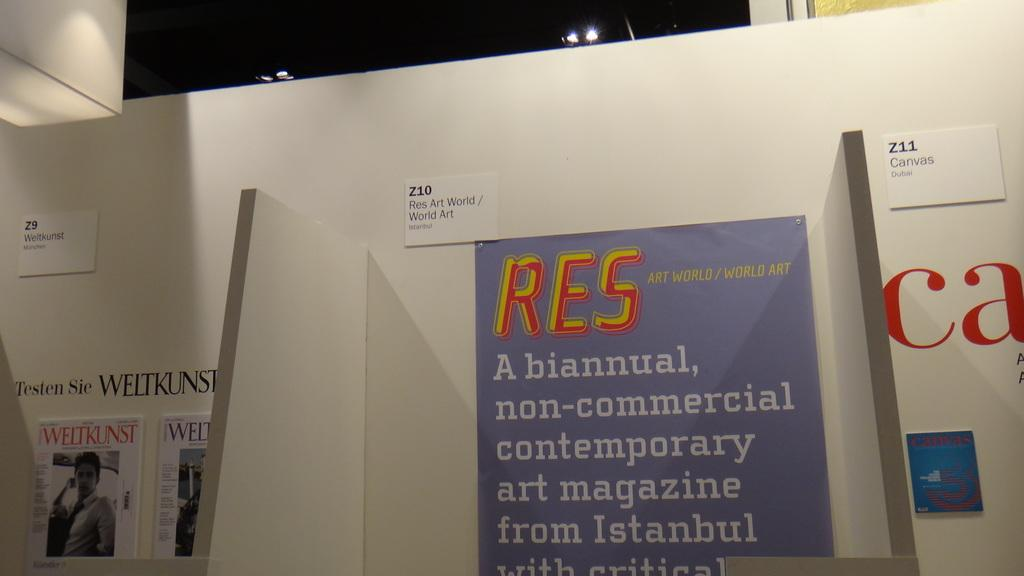<image>
Present a compact description of the photo's key features. An art gallery with a purple piece in the middle that says RES on top. 